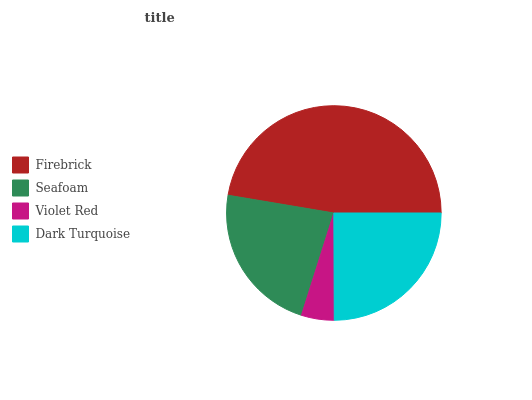Is Violet Red the minimum?
Answer yes or no. Yes. Is Firebrick the maximum?
Answer yes or no. Yes. Is Seafoam the minimum?
Answer yes or no. No. Is Seafoam the maximum?
Answer yes or no. No. Is Firebrick greater than Seafoam?
Answer yes or no. Yes. Is Seafoam less than Firebrick?
Answer yes or no. Yes. Is Seafoam greater than Firebrick?
Answer yes or no. No. Is Firebrick less than Seafoam?
Answer yes or no. No. Is Dark Turquoise the high median?
Answer yes or no. Yes. Is Seafoam the low median?
Answer yes or no. Yes. Is Firebrick the high median?
Answer yes or no. No. Is Firebrick the low median?
Answer yes or no. No. 